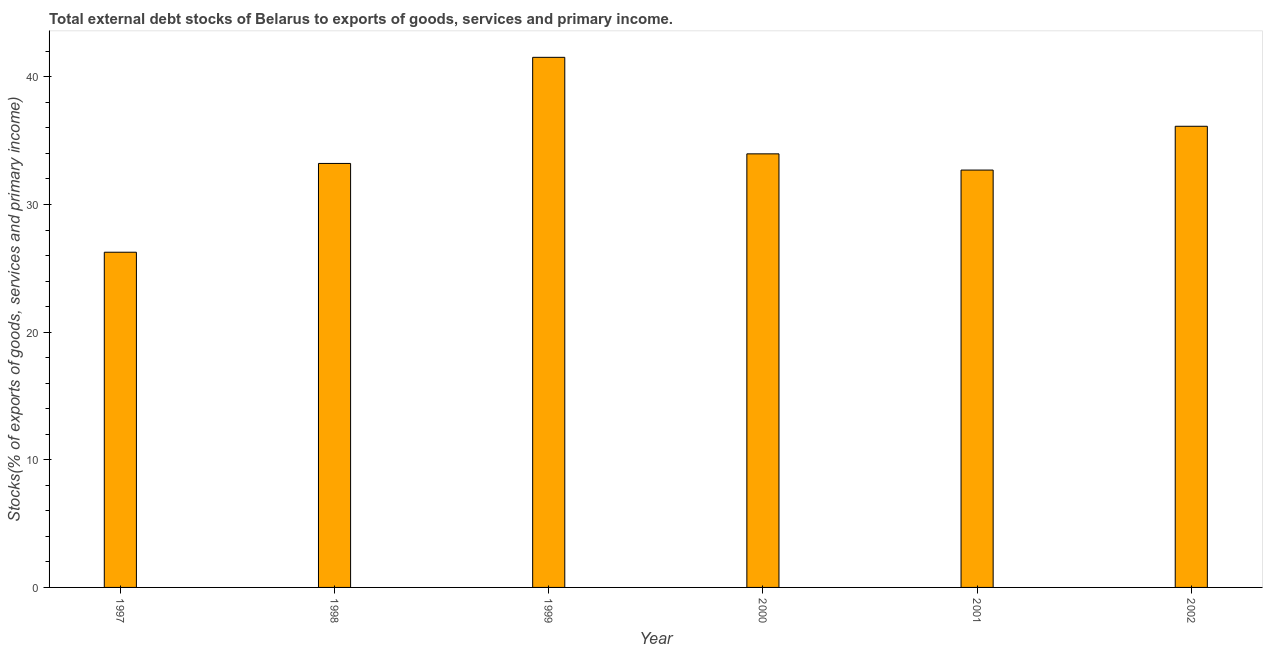Does the graph contain grids?
Give a very brief answer. No. What is the title of the graph?
Offer a very short reply. Total external debt stocks of Belarus to exports of goods, services and primary income. What is the label or title of the Y-axis?
Offer a very short reply. Stocks(% of exports of goods, services and primary income). What is the external debt stocks in 1997?
Your answer should be very brief. 26.26. Across all years, what is the maximum external debt stocks?
Make the answer very short. 41.53. Across all years, what is the minimum external debt stocks?
Offer a terse response. 26.26. What is the sum of the external debt stocks?
Your answer should be very brief. 203.8. What is the difference between the external debt stocks in 1997 and 2002?
Provide a succinct answer. -9.87. What is the average external debt stocks per year?
Make the answer very short. 33.97. What is the median external debt stocks?
Ensure brevity in your answer.  33.59. Do a majority of the years between 2002 and 1998 (inclusive) have external debt stocks greater than 12 %?
Give a very brief answer. Yes. What is the ratio of the external debt stocks in 1997 to that in 2000?
Your answer should be very brief. 0.77. Is the external debt stocks in 1998 less than that in 2001?
Ensure brevity in your answer.  No. Is the difference between the external debt stocks in 1997 and 2000 greater than the difference between any two years?
Provide a succinct answer. No. What is the difference between the highest and the second highest external debt stocks?
Make the answer very short. 5.4. Is the sum of the external debt stocks in 1997 and 2000 greater than the maximum external debt stocks across all years?
Your response must be concise. Yes. What is the difference between the highest and the lowest external debt stocks?
Provide a succinct answer. 15.27. In how many years, is the external debt stocks greater than the average external debt stocks taken over all years?
Your answer should be very brief. 3. How many bars are there?
Provide a short and direct response. 6. Are all the bars in the graph horizontal?
Make the answer very short. No. What is the Stocks(% of exports of goods, services and primary income) of 1997?
Give a very brief answer. 26.26. What is the Stocks(% of exports of goods, services and primary income) in 1998?
Provide a succinct answer. 33.22. What is the Stocks(% of exports of goods, services and primary income) of 1999?
Make the answer very short. 41.53. What is the Stocks(% of exports of goods, services and primary income) of 2000?
Provide a short and direct response. 33.97. What is the Stocks(% of exports of goods, services and primary income) in 2001?
Offer a very short reply. 32.7. What is the Stocks(% of exports of goods, services and primary income) of 2002?
Your answer should be very brief. 36.13. What is the difference between the Stocks(% of exports of goods, services and primary income) in 1997 and 1998?
Ensure brevity in your answer.  -6.96. What is the difference between the Stocks(% of exports of goods, services and primary income) in 1997 and 1999?
Provide a short and direct response. -15.27. What is the difference between the Stocks(% of exports of goods, services and primary income) in 1997 and 2000?
Your answer should be compact. -7.71. What is the difference between the Stocks(% of exports of goods, services and primary income) in 1997 and 2001?
Keep it short and to the point. -6.44. What is the difference between the Stocks(% of exports of goods, services and primary income) in 1997 and 2002?
Provide a succinct answer. -9.87. What is the difference between the Stocks(% of exports of goods, services and primary income) in 1998 and 1999?
Provide a short and direct response. -8.31. What is the difference between the Stocks(% of exports of goods, services and primary income) in 1998 and 2000?
Make the answer very short. -0.75. What is the difference between the Stocks(% of exports of goods, services and primary income) in 1998 and 2001?
Offer a terse response. 0.52. What is the difference between the Stocks(% of exports of goods, services and primary income) in 1998 and 2002?
Your answer should be very brief. -2.91. What is the difference between the Stocks(% of exports of goods, services and primary income) in 1999 and 2000?
Make the answer very short. 7.56. What is the difference between the Stocks(% of exports of goods, services and primary income) in 1999 and 2001?
Provide a short and direct response. 8.83. What is the difference between the Stocks(% of exports of goods, services and primary income) in 1999 and 2002?
Ensure brevity in your answer.  5.4. What is the difference between the Stocks(% of exports of goods, services and primary income) in 2000 and 2001?
Ensure brevity in your answer.  1.27. What is the difference between the Stocks(% of exports of goods, services and primary income) in 2000 and 2002?
Your answer should be compact. -2.16. What is the difference between the Stocks(% of exports of goods, services and primary income) in 2001 and 2002?
Your answer should be very brief. -3.43. What is the ratio of the Stocks(% of exports of goods, services and primary income) in 1997 to that in 1998?
Offer a terse response. 0.79. What is the ratio of the Stocks(% of exports of goods, services and primary income) in 1997 to that in 1999?
Make the answer very short. 0.63. What is the ratio of the Stocks(% of exports of goods, services and primary income) in 1997 to that in 2000?
Your response must be concise. 0.77. What is the ratio of the Stocks(% of exports of goods, services and primary income) in 1997 to that in 2001?
Provide a succinct answer. 0.8. What is the ratio of the Stocks(% of exports of goods, services and primary income) in 1997 to that in 2002?
Ensure brevity in your answer.  0.73. What is the ratio of the Stocks(% of exports of goods, services and primary income) in 1998 to that in 1999?
Provide a succinct answer. 0.8. What is the ratio of the Stocks(% of exports of goods, services and primary income) in 1998 to that in 2000?
Keep it short and to the point. 0.98. What is the ratio of the Stocks(% of exports of goods, services and primary income) in 1998 to that in 2002?
Your answer should be compact. 0.92. What is the ratio of the Stocks(% of exports of goods, services and primary income) in 1999 to that in 2000?
Provide a short and direct response. 1.22. What is the ratio of the Stocks(% of exports of goods, services and primary income) in 1999 to that in 2001?
Give a very brief answer. 1.27. What is the ratio of the Stocks(% of exports of goods, services and primary income) in 1999 to that in 2002?
Provide a succinct answer. 1.15. What is the ratio of the Stocks(% of exports of goods, services and primary income) in 2000 to that in 2001?
Ensure brevity in your answer.  1.04. What is the ratio of the Stocks(% of exports of goods, services and primary income) in 2001 to that in 2002?
Make the answer very short. 0.91. 